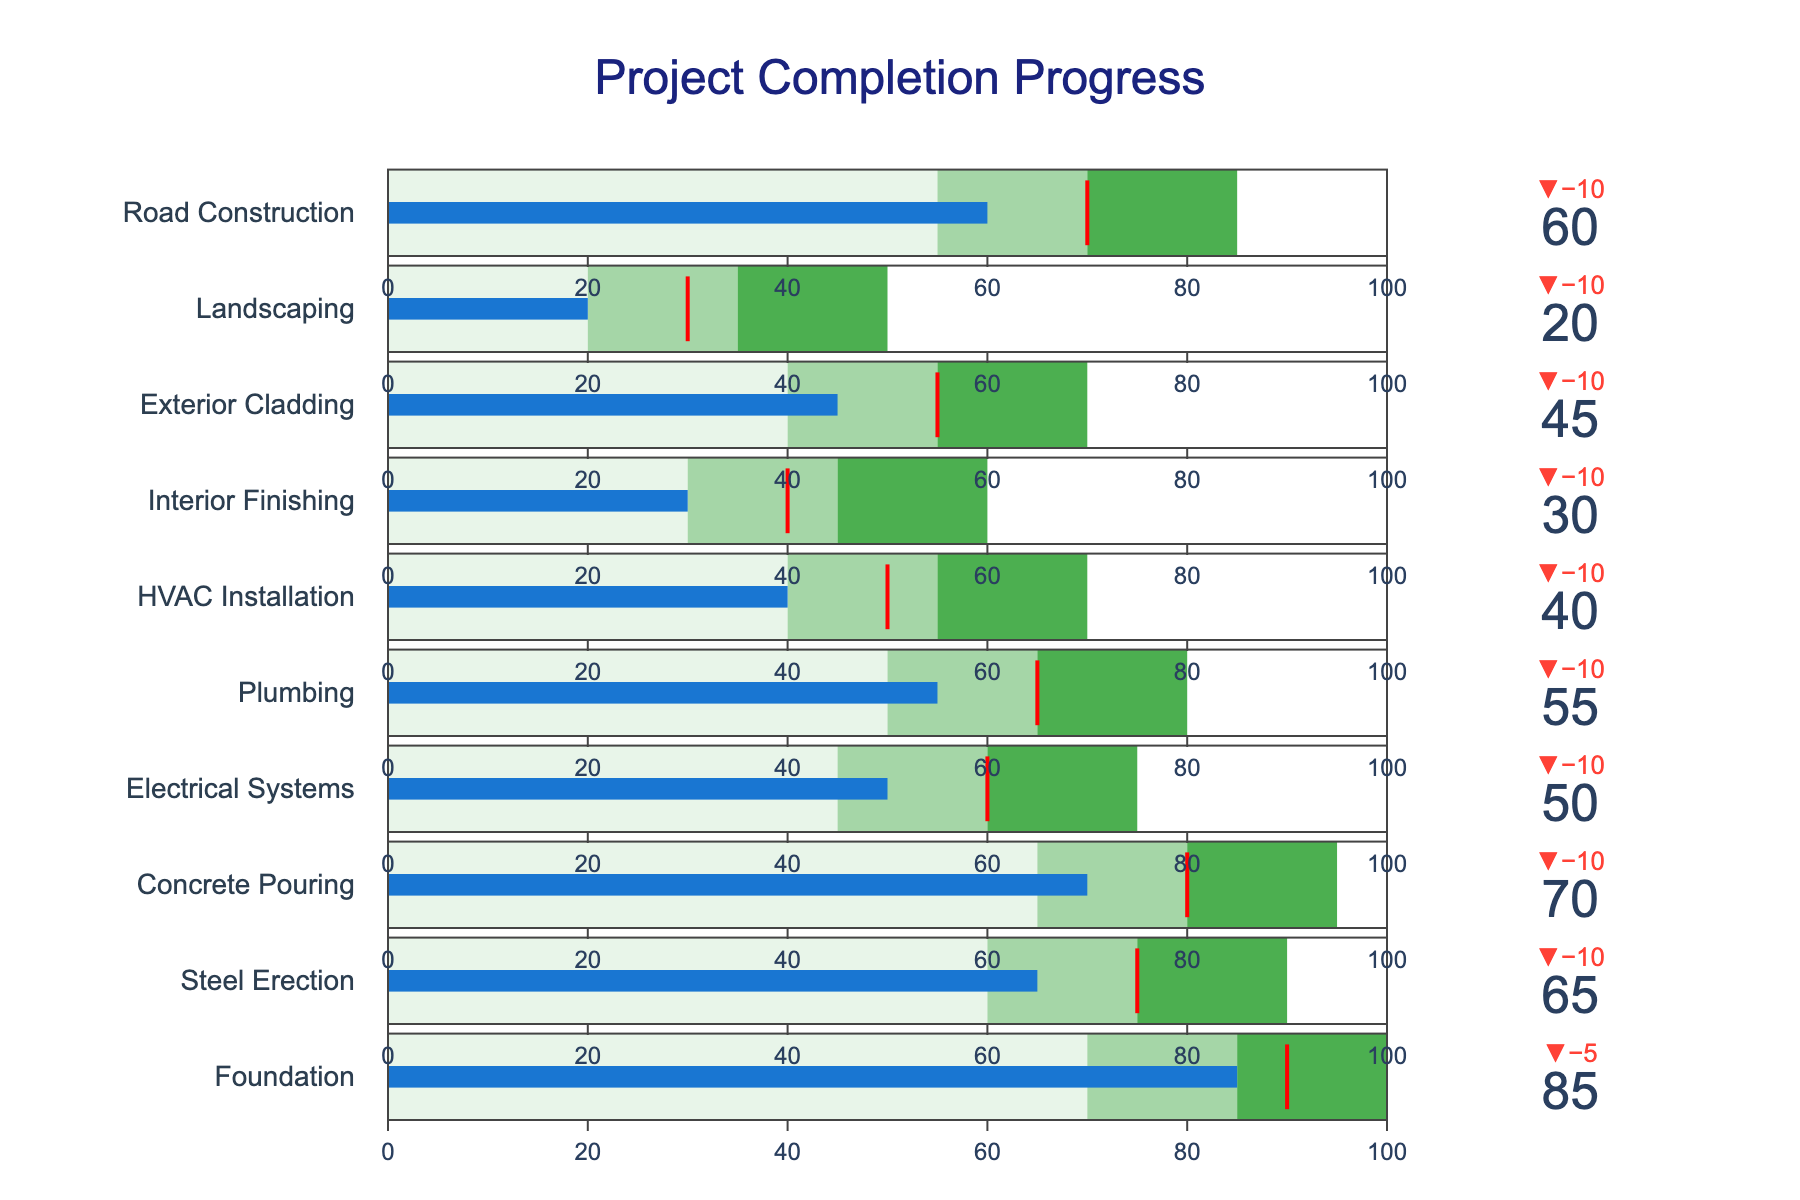what is the title of this figure? The title is located at the top-center of the figure and reads "Project Completion Progress."
Answer: Project Completion Progress which category has the highest actual value? Examine the "Actual" values of all categories. The highest value is for "Foundation" at 85.
Answer: Foundation what is the target value for Electrical Systems? Look at the target bullet value for "Electrical Systems." It is indicated in red at 60.
Answer: 60 how does the Plumbing completion compare to its target? The Plumbing "Actual" value is 55, and the target (red line) is 65, so Plumbing is 10 units below its target.
Answer: 10 units below which categories have actual values below their low-range thresholds? Identify categories where the "Actual" values are less than their "Low" thresholds. These are "HVAC Installation," "Interior Finishing," and "Landscaping."
Answer: HVAC Installation, Interior Finishing, Landscaping what is the range of target values across all categories? The lowest target value is for "HVAC Installation" at 50, and the highest target value is for "Foundation" at 90. So, the range is 90 - 50 = 40.
Answer: 40 which category has the smallest gap between its actual and target values? Calculate the differences between target and actual values for each category and find the smallest gap. "Foundation" has the smallest gap with a difference of 5.
Answer: Foundation what is the average actual value for all categories? Sum all actual values and divide by the number of categories: (85 + 65 + 70 + 50 + 55 + 40 + 30 + 45 + 20 + 60) / 10 = 52.
Answer: 52 which category is furthest from achieving its target? Find the category with the largest negative difference between actual and target values. "Landscaping" is 10 units short from its target value of 30.
Answer: Landscaping what percentage of the target is Landscaping's actual value? Calculate the percentage of the target value for Landscaping: (Actual / Target) * 100 = (20 / 30) * 100 = 66.67%.
Answer: 66.67% 